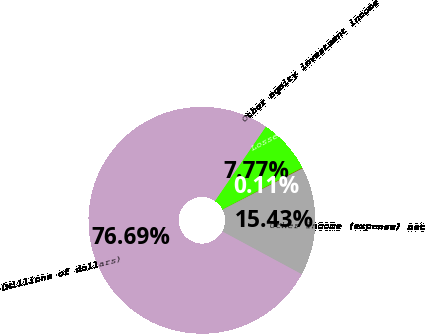Convert chart to OTSL. <chart><loc_0><loc_0><loc_500><loc_500><pie_chart><fcel>(Millions of dollars)<fcel>Other equity investment income<fcel>Losses on undesignated foreign<fcel>Other income (expense) net<nl><fcel>76.69%<fcel>7.77%<fcel>0.11%<fcel>15.43%<nl></chart> 